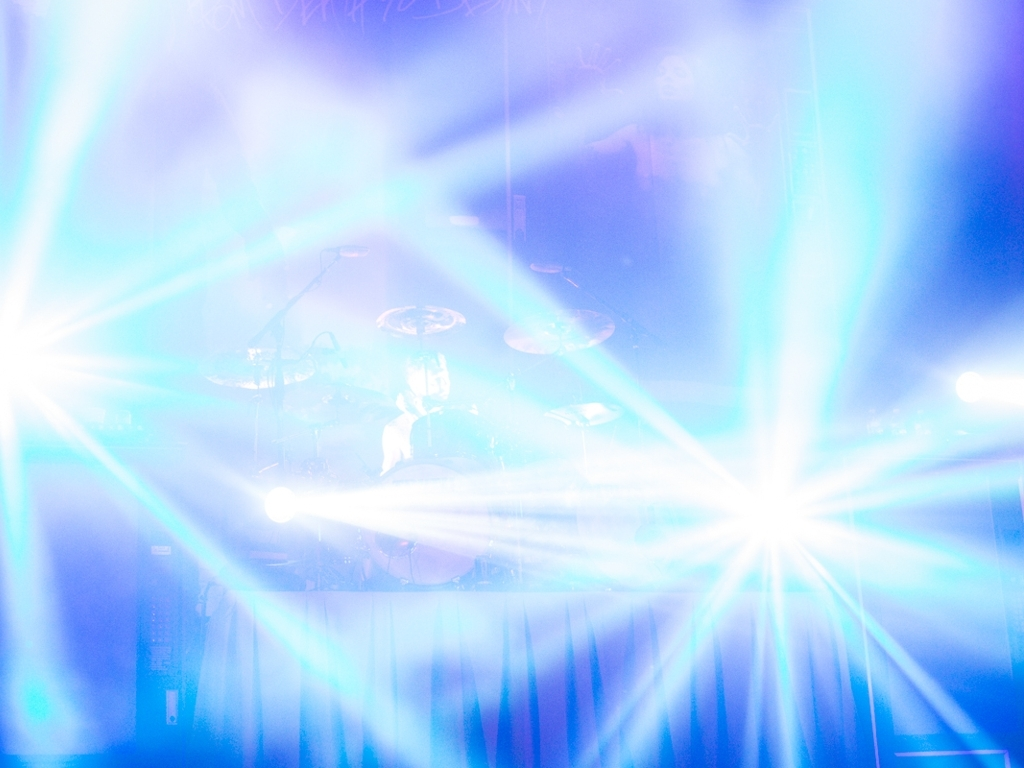Can you describe the mood or atmosphere you extrapolate from this image? The atmosphere in the image seems lively and energetic, typical of a music concert. The overexposed lights create a sense of excitement and indicate that something vibrant and high-energy is taking place. 